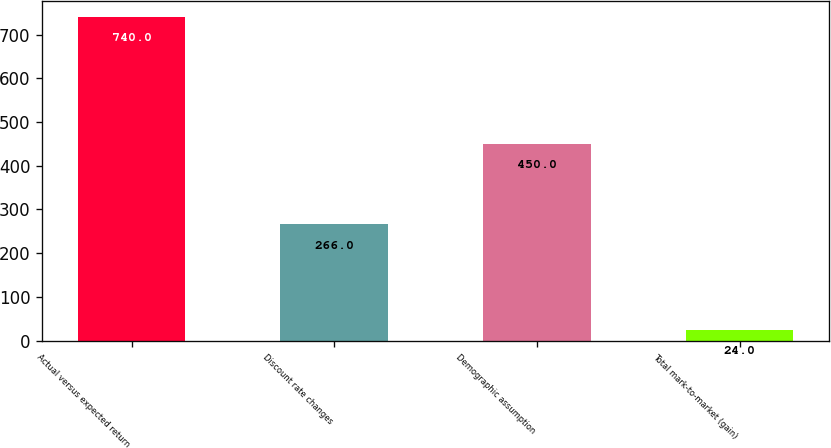Convert chart. <chart><loc_0><loc_0><loc_500><loc_500><bar_chart><fcel>Actual versus expected return<fcel>Discount rate changes<fcel>Demographic assumption<fcel>Total mark-to-market (gain)<nl><fcel>740<fcel>266<fcel>450<fcel>24<nl></chart> 